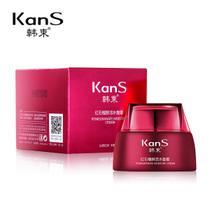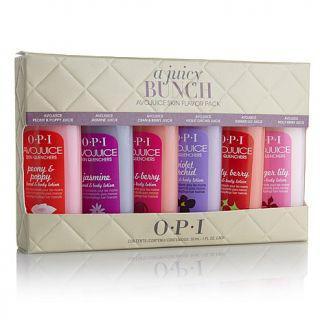The first image is the image on the left, the second image is the image on the right. Examine the images to the left and right. Is the description "At least one image features a single pump-top product." accurate? Answer yes or no. No. 